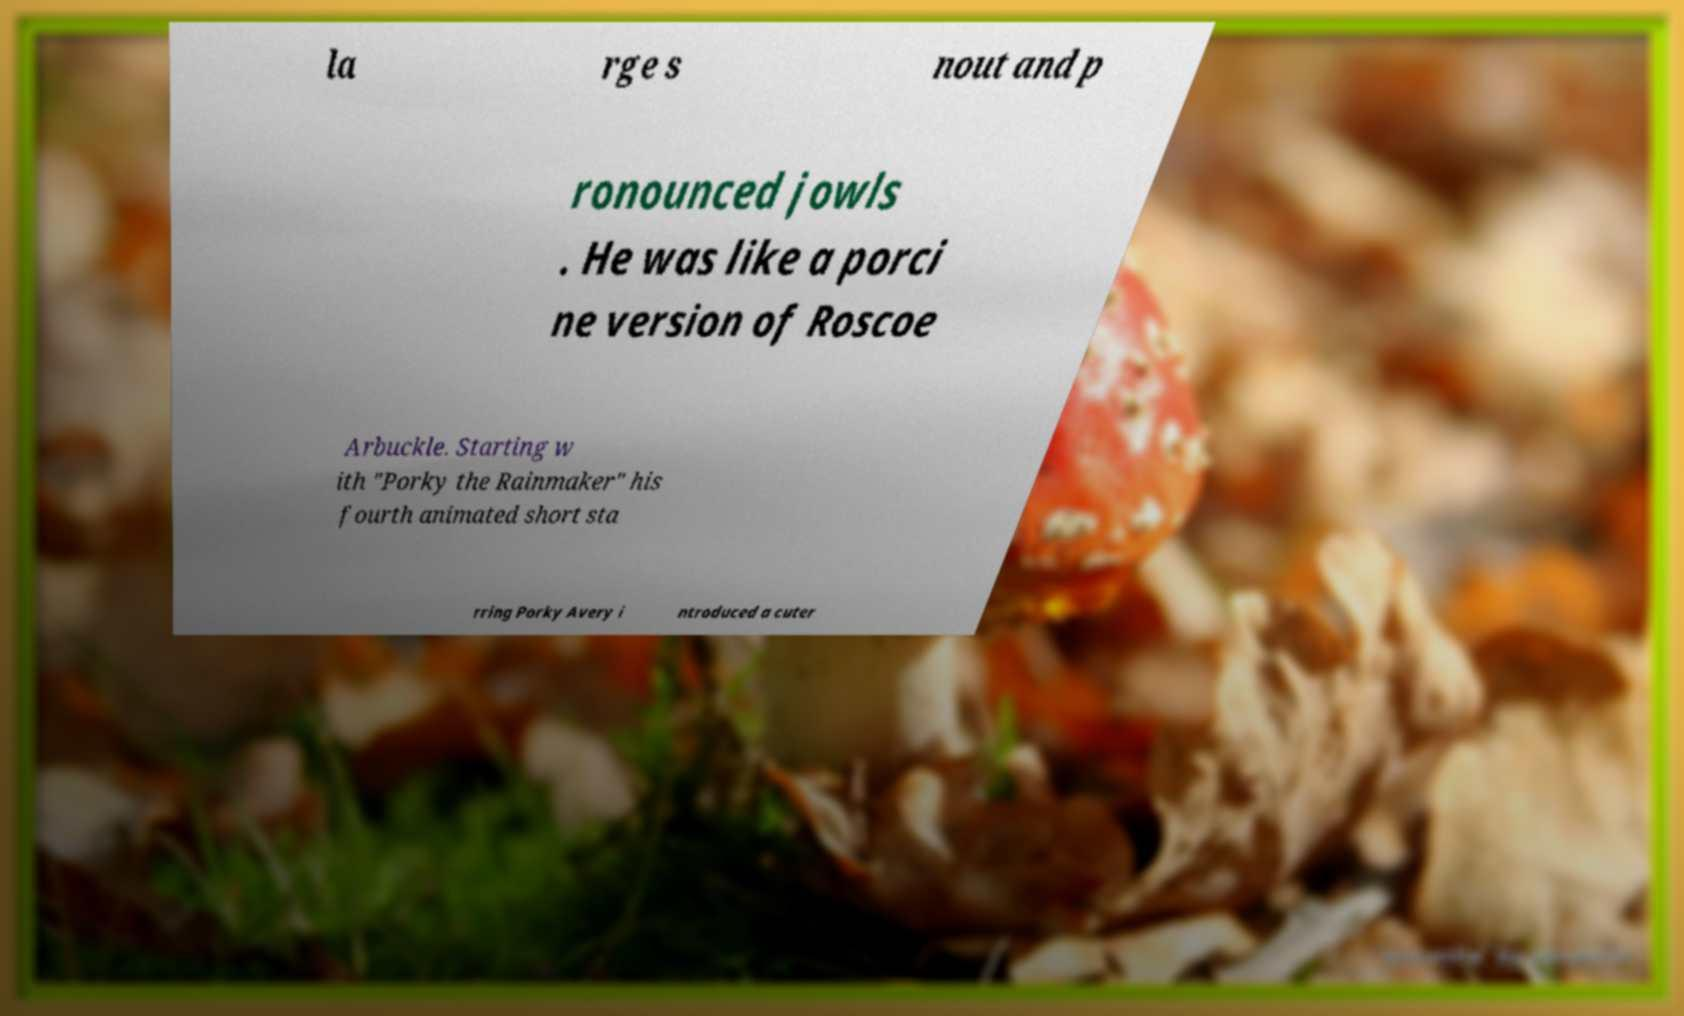Could you assist in decoding the text presented in this image and type it out clearly? la rge s nout and p ronounced jowls . He was like a porci ne version of Roscoe Arbuckle. Starting w ith "Porky the Rainmaker" his fourth animated short sta rring Porky Avery i ntroduced a cuter 